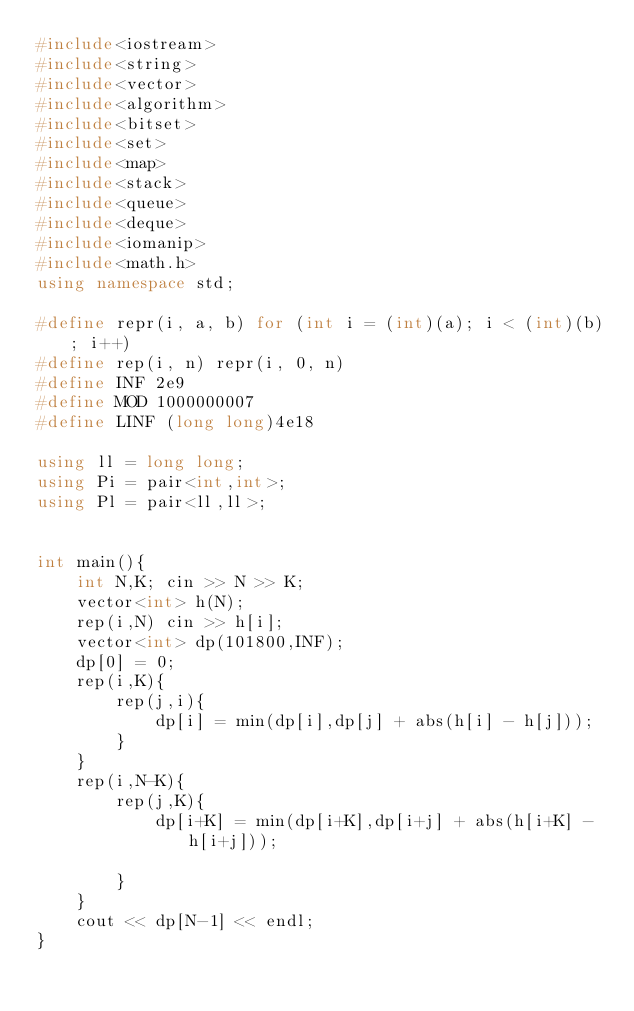<code> <loc_0><loc_0><loc_500><loc_500><_C++_>#include<iostream>
#include<string>
#include<vector>
#include<algorithm>
#include<bitset>
#include<set>
#include<map>
#include<stack>
#include<queue>
#include<deque>
#include<iomanip>
#include<math.h>
using namespace std;

#define repr(i, a, b) for (int i = (int)(a); i < (int)(b); i++)
#define rep(i, n) repr(i, 0, n)
#define INF 2e9
#define MOD 1000000007
#define LINF (long long)4e18

using ll = long long;
using Pi = pair<int,int>;
using Pl = pair<ll,ll>;


int main(){
    int N,K; cin >> N >> K;
    vector<int> h(N);
    rep(i,N) cin >> h[i];
    vector<int> dp(101800,INF);
    dp[0] = 0;
    rep(i,K){
        rep(j,i){
            dp[i] = min(dp[i],dp[j] + abs(h[i] - h[j]));
        }
    }
    rep(i,N-K){
        rep(j,K){
            dp[i+K] = min(dp[i+K],dp[i+j] + abs(h[i+K] - h[i+j]));
            
        }
    }
    cout << dp[N-1] << endl; 
}
</code> 